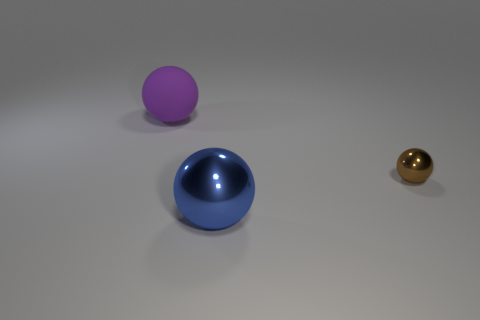Which sphere appears to be closest to the viewer in this image? The large blue sphere appears to be the closest to the viewer, placed prominently in the foreground. And can you infer anything about the size of the spheres relative to each other? Although perspective can affect perception, the blue sphere appears to be the largest, the purple one is medium-sized and further away, while the shiny gold sphere looks to be the smallest and farthest. 